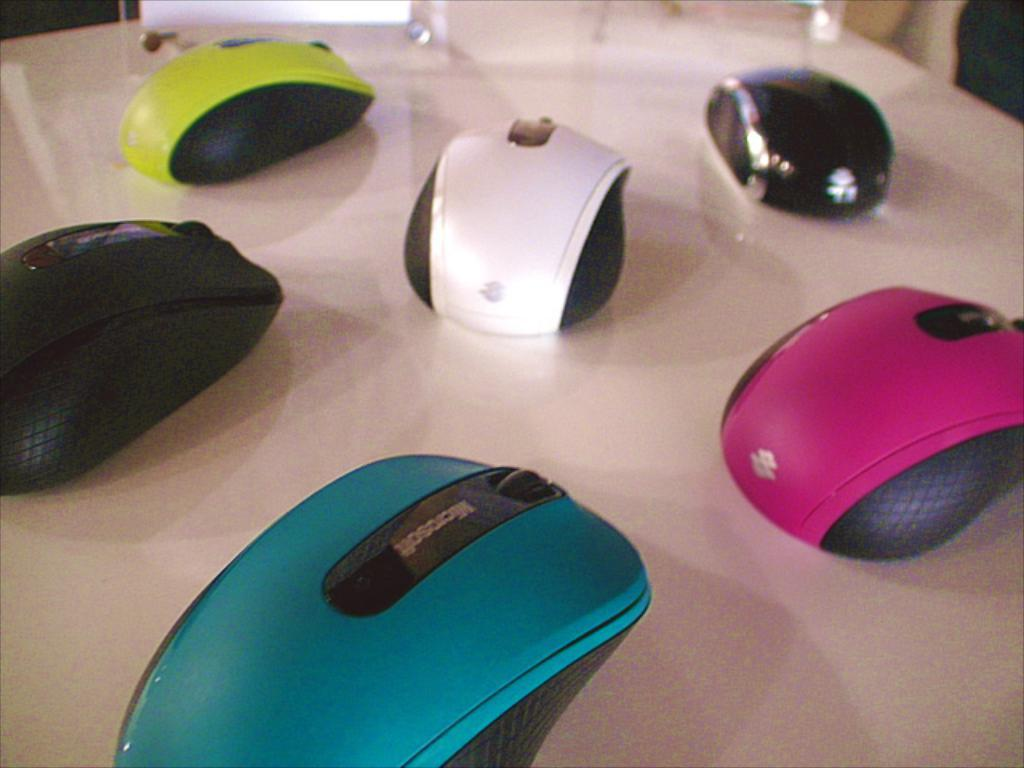What is the primary color of the surface in the image? The surface in the image is white. What type of animals can be seen on the white surface? There are different colored mice on the white surface. Can you see any fairies interacting with the mice on the white surface? There are no fairies present in the image; it only features different colored mice on a white surface. 